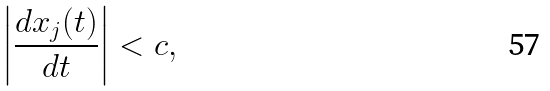<formula> <loc_0><loc_0><loc_500><loc_500>\left | \frac { d { x } _ { j } ( t ) } { d t } \right | < c ,</formula> 